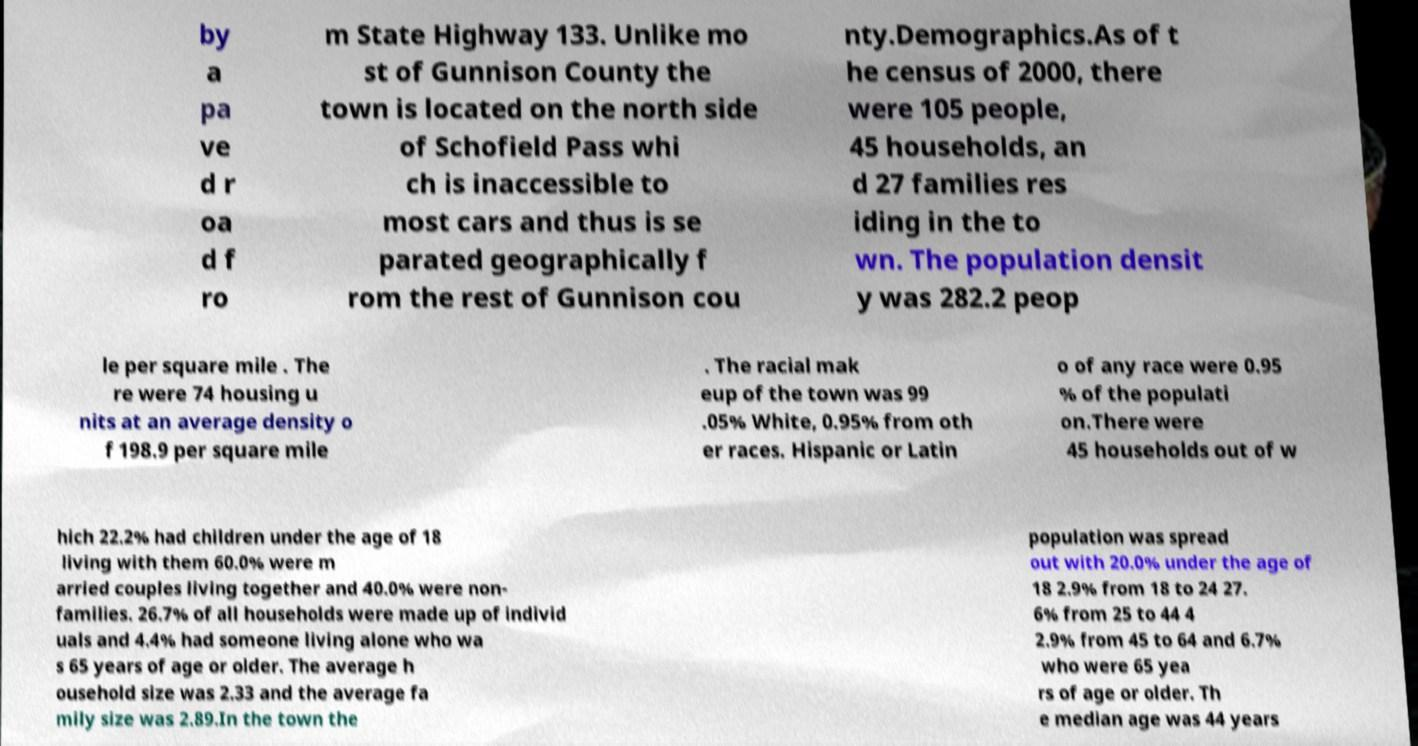Can you accurately transcribe the text from the provided image for me? by a pa ve d r oa d f ro m State Highway 133. Unlike mo st of Gunnison County the town is located on the north side of Schofield Pass whi ch is inaccessible to most cars and thus is se parated geographically f rom the rest of Gunnison cou nty.Demographics.As of t he census of 2000, there were 105 people, 45 households, an d 27 families res iding in the to wn. The population densit y was 282.2 peop le per square mile . The re were 74 housing u nits at an average density o f 198.9 per square mile . The racial mak eup of the town was 99 .05% White, 0.95% from oth er races. Hispanic or Latin o of any race were 0.95 % of the populati on.There were 45 households out of w hich 22.2% had children under the age of 18 living with them 60.0% were m arried couples living together and 40.0% were non- families. 26.7% of all households were made up of individ uals and 4.4% had someone living alone who wa s 65 years of age or older. The average h ousehold size was 2.33 and the average fa mily size was 2.89.In the town the population was spread out with 20.0% under the age of 18 2.9% from 18 to 24 27. 6% from 25 to 44 4 2.9% from 45 to 64 and 6.7% who were 65 yea rs of age or older. Th e median age was 44 years 